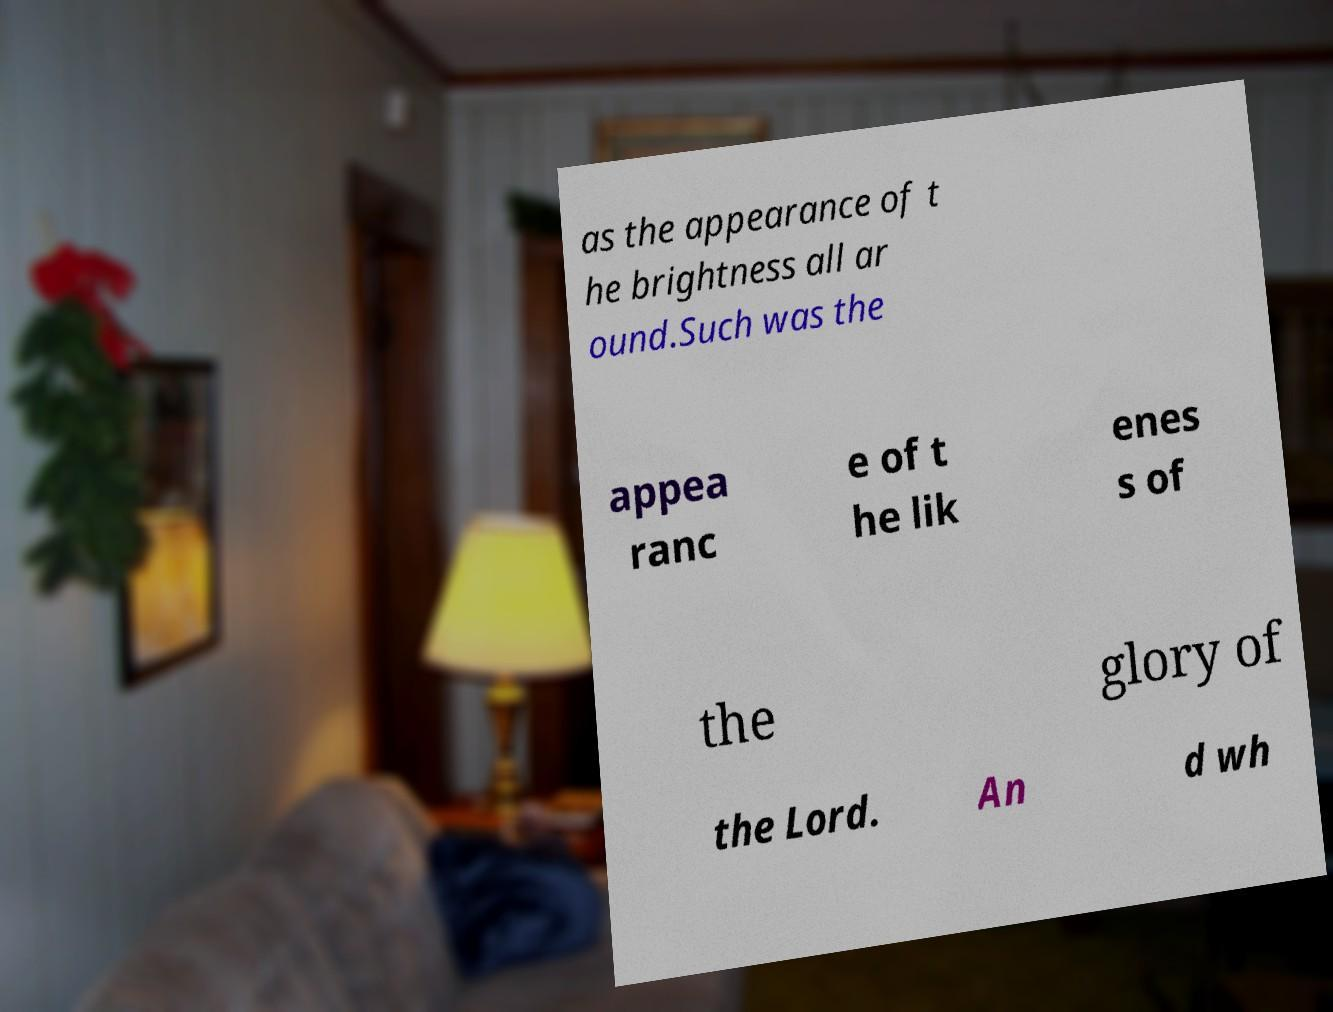Can you accurately transcribe the text from the provided image for me? as the appearance of t he brightness all ar ound.Such was the appea ranc e of t he lik enes s of the glory of the Lord. An d wh 